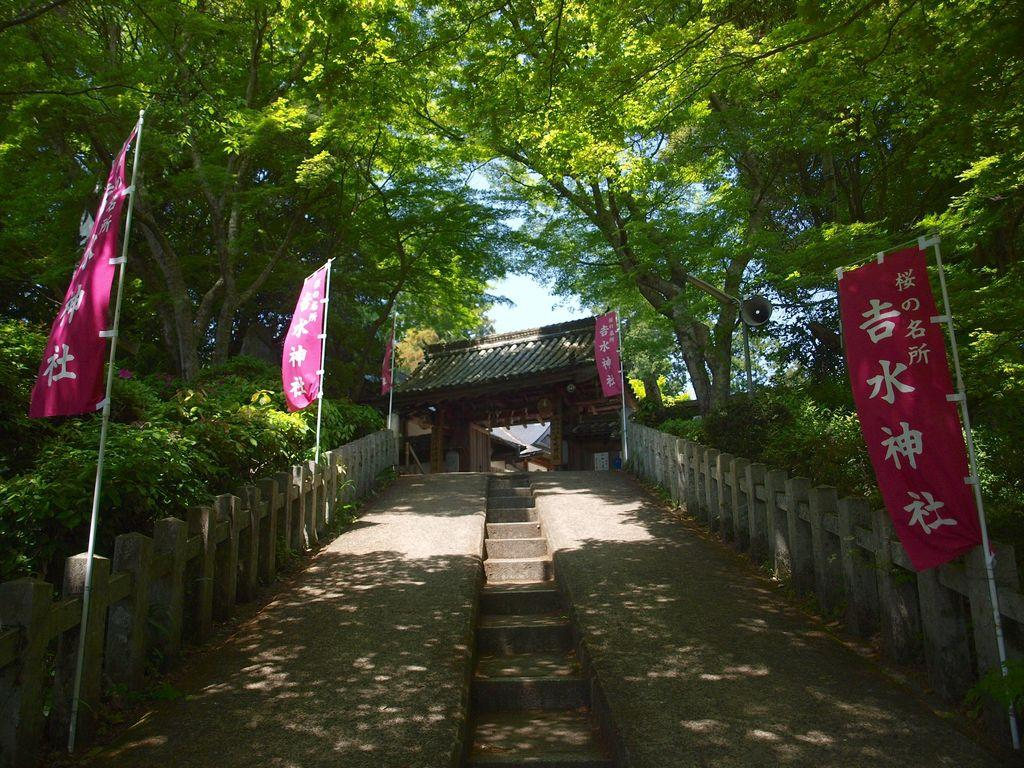What structure is located in the center of the image? There is a shed in the center of the image. What can be seen at the bottom of the image? There are stairs visible at the bottom of the image. What decorative elements are present in the image? Flags are visible in the image. What type of natural environment is visible in the background of the image? There are trees and the sky visible in the background of the image. How does the stem of the tree in the image jump from one branch to another? There is no stem or tree present in the image; it features a shed, stairs, flags, and a background with trees and the sky. 